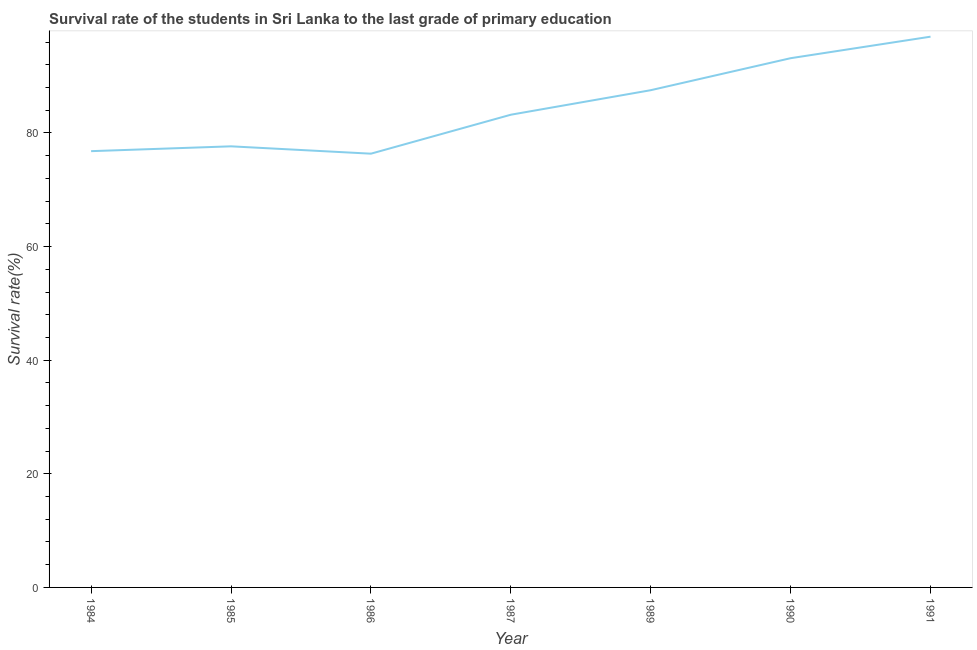What is the survival rate in primary education in 1986?
Keep it short and to the point. 76.35. Across all years, what is the maximum survival rate in primary education?
Keep it short and to the point. 96.94. Across all years, what is the minimum survival rate in primary education?
Provide a succinct answer. 76.35. What is the sum of the survival rate in primary education?
Make the answer very short. 591.61. What is the difference between the survival rate in primary education in 1985 and 1986?
Provide a short and direct response. 1.29. What is the average survival rate in primary education per year?
Provide a succinct answer. 84.52. What is the median survival rate in primary education?
Ensure brevity in your answer.  83.21. Do a majority of the years between 1990 and 1985 (inclusive) have survival rate in primary education greater than 72 %?
Keep it short and to the point. Yes. What is the ratio of the survival rate in primary education in 1984 to that in 1986?
Your answer should be compact. 1.01. Is the difference between the survival rate in primary education in 1984 and 1985 greater than the difference between any two years?
Offer a very short reply. No. What is the difference between the highest and the second highest survival rate in primary education?
Provide a short and direct response. 3.79. What is the difference between the highest and the lowest survival rate in primary education?
Make the answer very short. 20.6. In how many years, is the survival rate in primary education greater than the average survival rate in primary education taken over all years?
Provide a short and direct response. 3. How many lines are there?
Keep it short and to the point. 1. Does the graph contain any zero values?
Provide a short and direct response. No. What is the title of the graph?
Your response must be concise. Survival rate of the students in Sri Lanka to the last grade of primary education. What is the label or title of the X-axis?
Your answer should be very brief. Year. What is the label or title of the Y-axis?
Give a very brief answer. Survival rate(%). What is the Survival rate(%) of 1984?
Your response must be concise. 76.79. What is the Survival rate(%) of 1985?
Ensure brevity in your answer.  77.64. What is the Survival rate(%) of 1986?
Give a very brief answer. 76.35. What is the Survival rate(%) of 1987?
Give a very brief answer. 83.21. What is the Survival rate(%) in 1989?
Ensure brevity in your answer.  87.52. What is the Survival rate(%) of 1990?
Offer a terse response. 93.16. What is the Survival rate(%) in 1991?
Offer a very short reply. 96.94. What is the difference between the Survival rate(%) in 1984 and 1985?
Provide a succinct answer. -0.85. What is the difference between the Survival rate(%) in 1984 and 1986?
Make the answer very short. 0.44. What is the difference between the Survival rate(%) in 1984 and 1987?
Provide a succinct answer. -6.41. What is the difference between the Survival rate(%) in 1984 and 1989?
Your response must be concise. -10.73. What is the difference between the Survival rate(%) in 1984 and 1990?
Keep it short and to the point. -16.36. What is the difference between the Survival rate(%) in 1984 and 1991?
Offer a terse response. -20.15. What is the difference between the Survival rate(%) in 1985 and 1986?
Ensure brevity in your answer.  1.29. What is the difference between the Survival rate(%) in 1985 and 1987?
Keep it short and to the point. -5.56. What is the difference between the Survival rate(%) in 1985 and 1989?
Provide a short and direct response. -9.88. What is the difference between the Survival rate(%) in 1985 and 1990?
Provide a short and direct response. -15.51. What is the difference between the Survival rate(%) in 1985 and 1991?
Keep it short and to the point. -19.3. What is the difference between the Survival rate(%) in 1986 and 1987?
Your answer should be very brief. -6.86. What is the difference between the Survival rate(%) in 1986 and 1989?
Keep it short and to the point. -11.17. What is the difference between the Survival rate(%) in 1986 and 1990?
Provide a short and direct response. -16.81. What is the difference between the Survival rate(%) in 1986 and 1991?
Provide a short and direct response. -20.6. What is the difference between the Survival rate(%) in 1987 and 1989?
Give a very brief answer. -4.32. What is the difference between the Survival rate(%) in 1987 and 1990?
Offer a very short reply. -9.95. What is the difference between the Survival rate(%) in 1987 and 1991?
Make the answer very short. -13.74. What is the difference between the Survival rate(%) in 1989 and 1990?
Offer a very short reply. -5.63. What is the difference between the Survival rate(%) in 1989 and 1991?
Give a very brief answer. -9.42. What is the difference between the Survival rate(%) in 1990 and 1991?
Provide a succinct answer. -3.79. What is the ratio of the Survival rate(%) in 1984 to that in 1987?
Ensure brevity in your answer.  0.92. What is the ratio of the Survival rate(%) in 1984 to that in 1989?
Provide a succinct answer. 0.88. What is the ratio of the Survival rate(%) in 1984 to that in 1990?
Your response must be concise. 0.82. What is the ratio of the Survival rate(%) in 1984 to that in 1991?
Offer a terse response. 0.79. What is the ratio of the Survival rate(%) in 1985 to that in 1987?
Your answer should be very brief. 0.93. What is the ratio of the Survival rate(%) in 1985 to that in 1989?
Ensure brevity in your answer.  0.89. What is the ratio of the Survival rate(%) in 1985 to that in 1990?
Make the answer very short. 0.83. What is the ratio of the Survival rate(%) in 1985 to that in 1991?
Give a very brief answer. 0.8. What is the ratio of the Survival rate(%) in 1986 to that in 1987?
Give a very brief answer. 0.92. What is the ratio of the Survival rate(%) in 1986 to that in 1989?
Your answer should be compact. 0.87. What is the ratio of the Survival rate(%) in 1986 to that in 1990?
Your response must be concise. 0.82. What is the ratio of the Survival rate(%) in 1986 to that in 1991?
Provide a succinct answer. 0.79. What is the ratio of the Survival rate(%) in 1987 to that in 1989?
Provide a succinct answer. 0.95. What is the ratio of the Survival rate(%) in 1987 to that in 1990?
Your answer should be compact. 0.89. What is the ratio of the Survival rate(%) in 1987 to that in 1991?
Your response must be concise. 0.86. What is the ratio of the Survival rate(%) in 1989 to that in 1990?
Offer a terse response. 0.94. What is the ratio of the Survival rate(%) in 1989 to that in 1991?
Offer a very short reply. 0.9. What is the ratio of the Survival rate(%) in 1990 to that in 1991?
Make the answer very short. 0.96. 